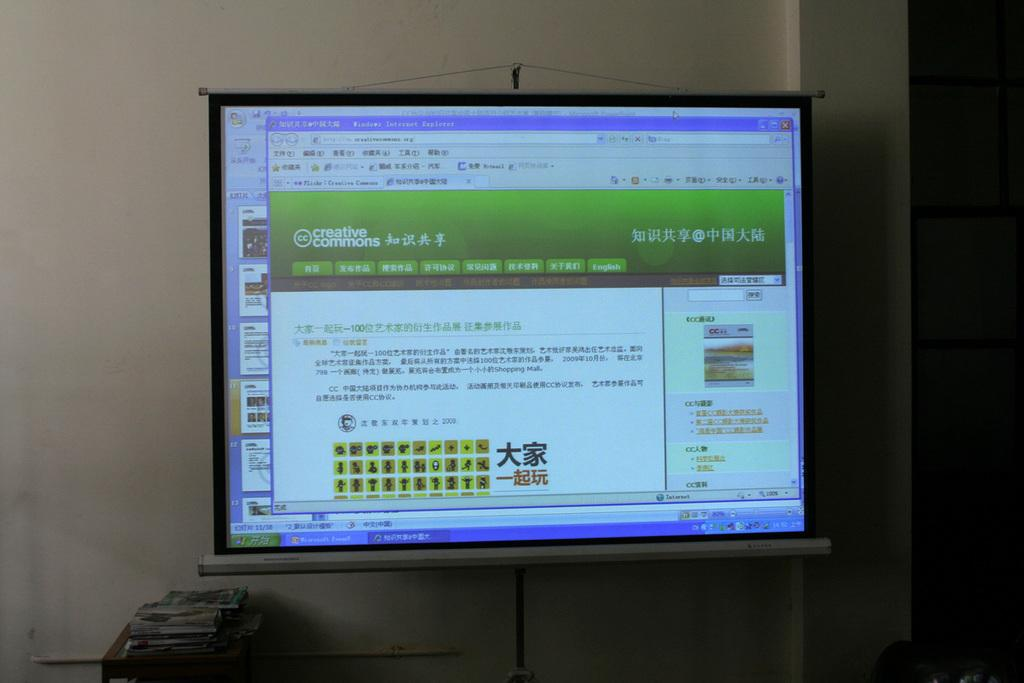<image>
Provide a brief description of the given image. A windows page open on a film screen to a page that says Creative Commons. 